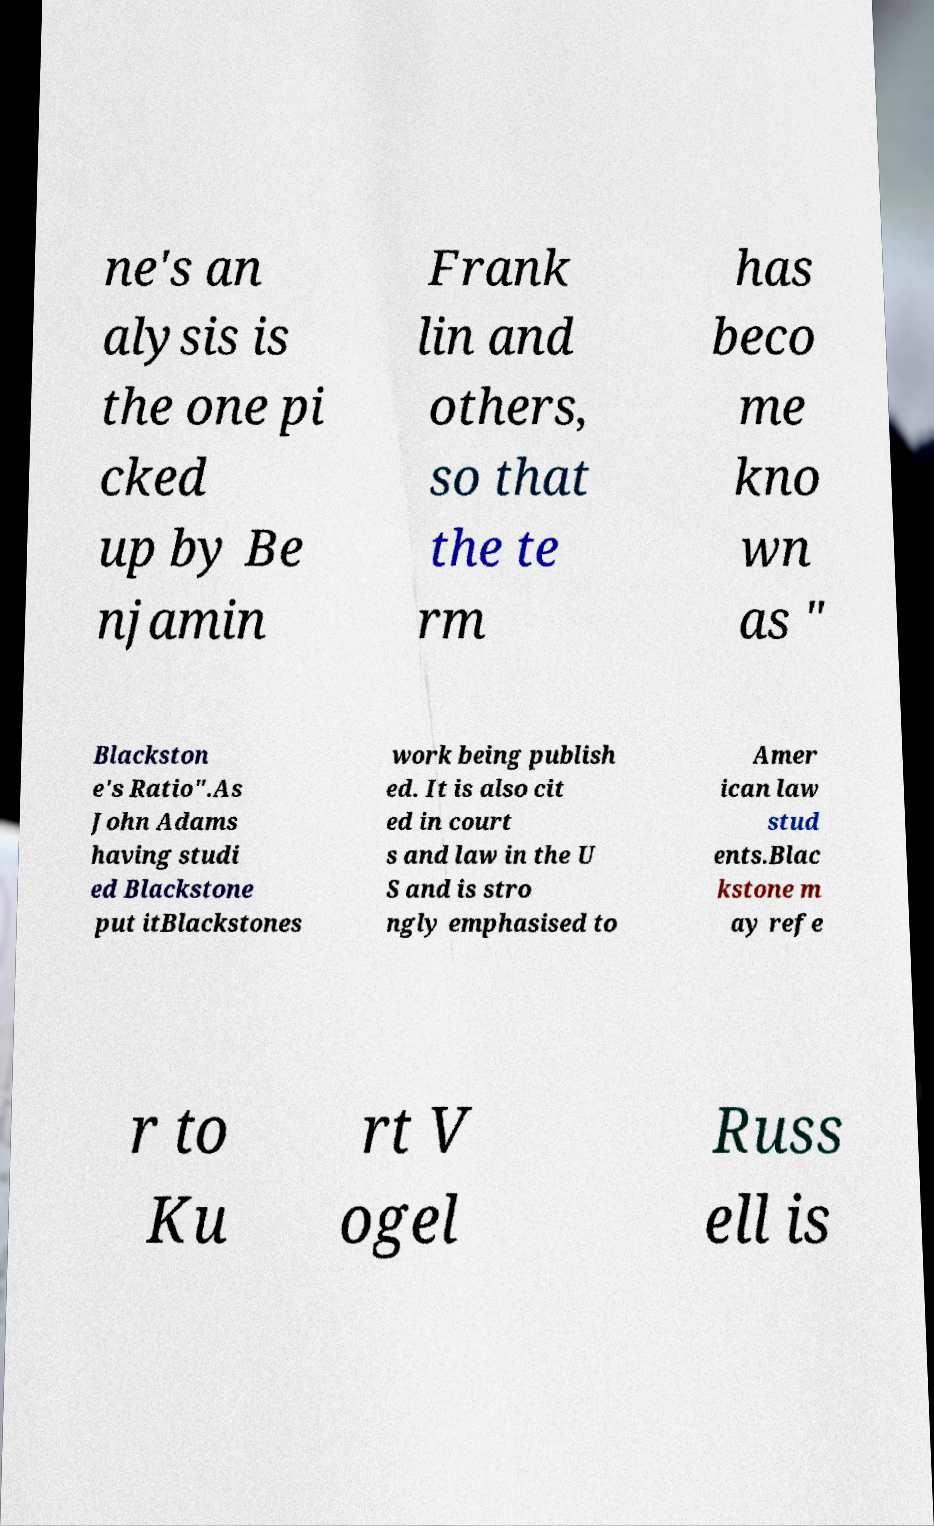Please read and relay the text visible in this image. What does it say? ne's an alysis is the one pi cked up by Be njamin Frank lin and others, so that the te rm has beco me kno wn as " Blackston e's Ratio".As John Adams having studi ed Blackstone put itBlackstones work being publish ed. It is also cit ed in court s and law in the U S and is stro ngly emphasised to Amer ican law stud ents.Blac kstone m ay refe r to Ku rt V ogel Russ ell is 